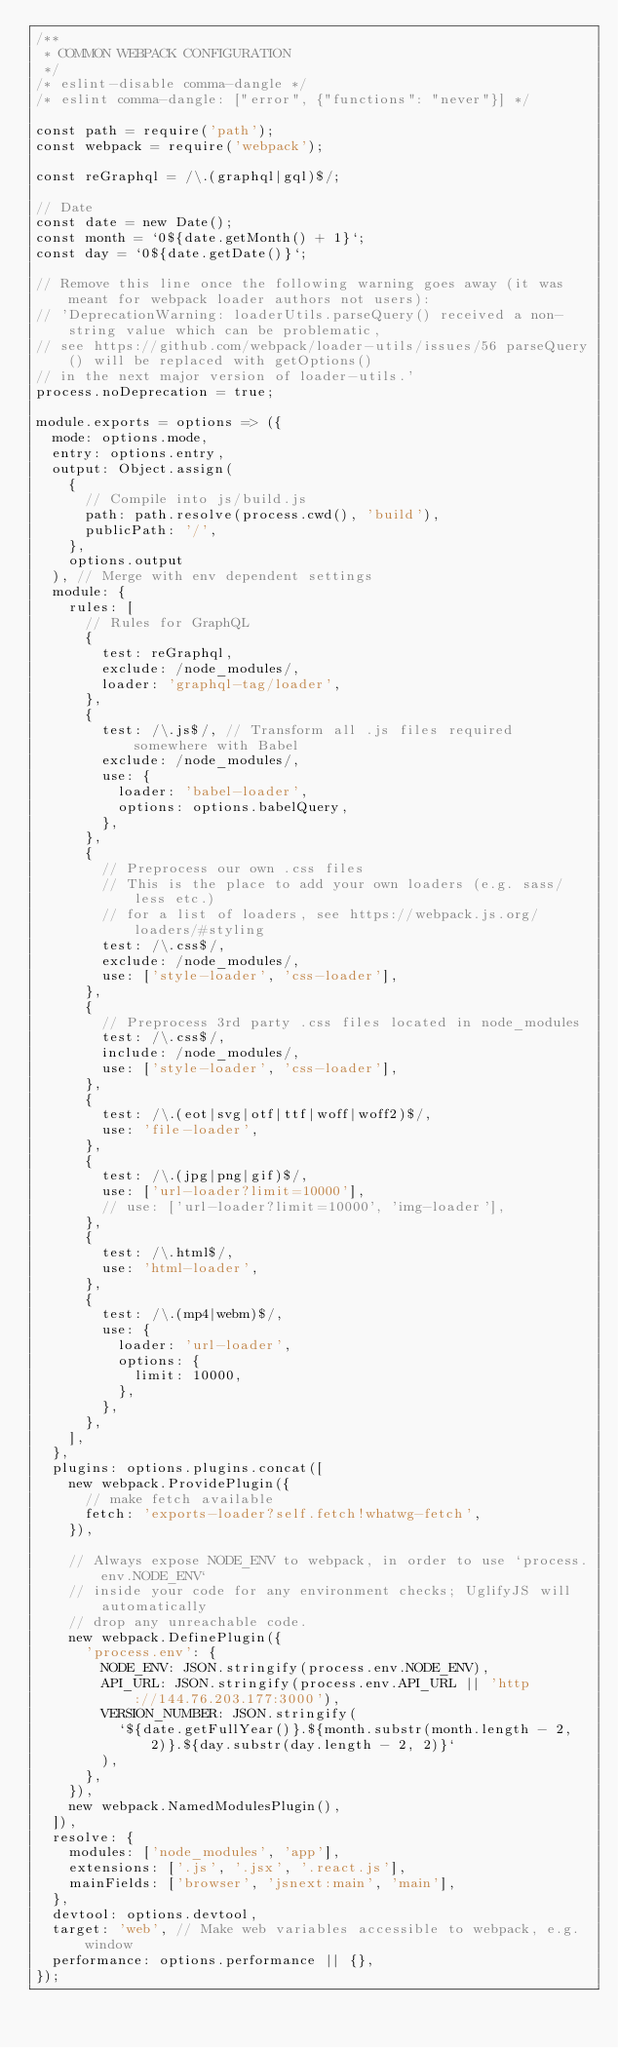<code> <loc_0><loc_0><loc_500><loc_500><_JavaScript_>/**
 * COMMON WEBPACK CONFIGURATION
 */
/* eslint-disable comma-dangle */
/* eslint comma-dangle: ["error", {"functions": "never"}] */

const path = require('path');
const webpack = require('webpack');

const reGraphql = /\.(graphql|gql)$/;

// Date
const date = new Date();
const month = `0${date.getMonth() + 1}`;
const day = `0${date.getDate()}`;

// Remove this line once the following warning goes away (it was meant for webpack loader authors not users):
// 'DeprecationWarning: loaderUtils.parseQuery() received a non-string value which can be problematic,
// see https://github.com/webpack/loader-utils/issues/56 parseQuery() will be replaced with getOptions()
// in the next major version of loader-utils.'
process.noDeprecation = true;

module.exports = options => ({
  mode: options.mode,
  entry: options.entry,
  output: Object.assign(
    {
      // Compile into js/build.js
      path: path.resolve(process.cwd(), 'build'),
      publicPath: '/',
    },
    options.output
  ), // Merge with env dependent settings
  module: {
    rules: [
      // Rules for GraphQL
      {
        test: reGraphql,
        exclude: /node_modules/,
        loader: 'graphql-tag/loader',
      },
      {
        test: /\.js$/, // Transform all .js files required somewhere with Babel
        exclude: /node_modules/,
        use: {
          loader: 'babel-loader',
          options: options.babelQuery,
        },
      },
      {
        // Preprocess our own .css files
        // This is the place to add your own loaders (e.g. sass/less etc.)
        // for a list of loaders, see https://webpack.js.org/loaders/#styling
        test: /\.css$/,
        exclude: /node_modules/,
        use: ['style-loader', 'css-loader'],
      },
      {
        // Preprocess 3rd party .css files located in node_modules
        test: /\.css$/,
        include: /node_modules/,
        use: ['style-loader', 'css-loader'],
      },
      {
        test: /\.(eot|svg|otf|ttf|woff|woff2)$/,
        use: 'file-loader',
      },
      {
        test: /\.(jpg|png|gif)$/,
        use: ['url-loader?limit=10000'],
        // use: ['url-loader?limit=10000', 'img-loader'],
      },
      {
        test: /\.html$/,
        use: 'html-loader',
      },
      {
        test: /\.(mp4|webm)$/,
        use: {
          loader: 'url-loader',
          options: {
            limit: 10000,
          },
        },
      },
    ],
  },
  plugins: options.plugins.concat([
    new webpack.ProvidePlugin({
      // make fetch available
      fetch: 'exports-loader?self.fetch!whatwg-fetch',
    }),

    // Always expose NODE_ENV to webpack, in order to use `process.env.NODE_ENV`
    // inside your code for any environment checks; UglifyJS will automatically
    // drop any unreachable code.
    new webpack.DefinePlugin({
      'process.env': {
        NODE_ENV: JSON.stringify(process.env.NODE_ENV),
        API_URL: JSON.stringify(process.env.API_URL || 'http://144.76.203.177:3000'),
        VERSION_NUMBER: JSON.stringify(
          `${date.getFullYear()}.${month.substr(month.length - 2, 2)}.${day.substr(day.length - 2, 2)}`
        ),
      },
    }),
    new webpack.NamedModulesPlugin(),
  ]),
  resolve: {
    modules: ['node_modules', 'app'],
    extensions: ['.js', '.jsx', '.react.js'],
    mainFields: ['browser', 'jsnext:main', 'main'],
  },
  devtool: options.devtool,
  target: 'web', // Make web variables accessible to webpack, e.g. window
  performance: options.performance || {},
});
</code> 